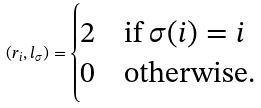Convert formula to latex. <formula><loc_0><loc_0><loc_500><loc_500>( r _ { i } , l _ { \sigma } ) = \begin{cases} 2 & \text {if $\sigma (i)=i$} \\ 0 & \text {otherwise} . \end{cases}</formula> 